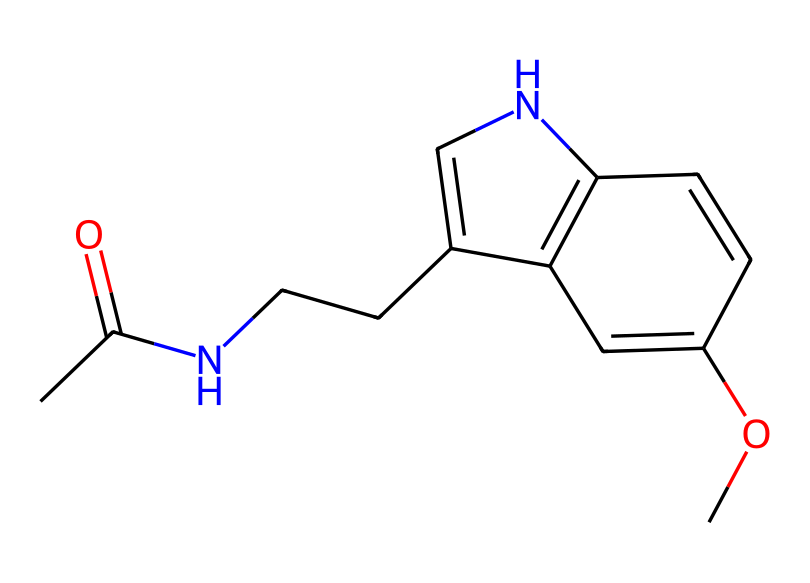how many carbon atoms are in this molecule? By examining the SMILES representation, we can identify the segments that indicate carbon atoms. Each "C" represents a carbon atom, so we count them in the structure to find the total number. The provided SMILES has 11 carbon atoms.
Answer: 11 what is the molecular formula of melatonin? The molecular formula can be derived by counting the different types of atoms represented in the SMILES. The breakdown includes 11 carbons, 13 hydrogens, 1 nitrogen, and 2 oxygens. Thus, the molecular formula is C13H16N2O2.
Answer: C13H16N2O2 how many double bonds are present in this structure? To determine the number of double bonds, we look for the "=" symbols in the SMILES representation, which indicate double bonds. There are two instances of "=" in the representation, signifying that there are 2 double bonds.
Answer: 2 what type of functional groups are present in melatonin? By analyzing the SMILES, we can identify functional groups through characteristic patterns. The presence of "CC(=O)" indicates a carbonyl (part of an acetamide), and the "OC" indicates the presence of an ether or alcohol group. Therefore, melatonin has carbonyl and methoxy functional groups.
Answer: carbonyl, methoxy which atom serves as a backbone in this hormone? The backbone of a molecule typically consists of carbon atoms, which in this case form the primary chain of the structure. Observing the SMILES indicates that the chain of carbon atoms (i.e., the main section) is represented at the start of the SMILES. This confirms that carbon atoms are the backbone for melatonin.
Answer: carbon how many nitrogen atoms are in melatonin? Analyzing the SMILES representation, we look for the letter "N," which denotes nitrogen atoms. Count the "N" symbols in the structure, revealing that there are 2 nitrogen atoms present in melatonin.
Answer: 2 